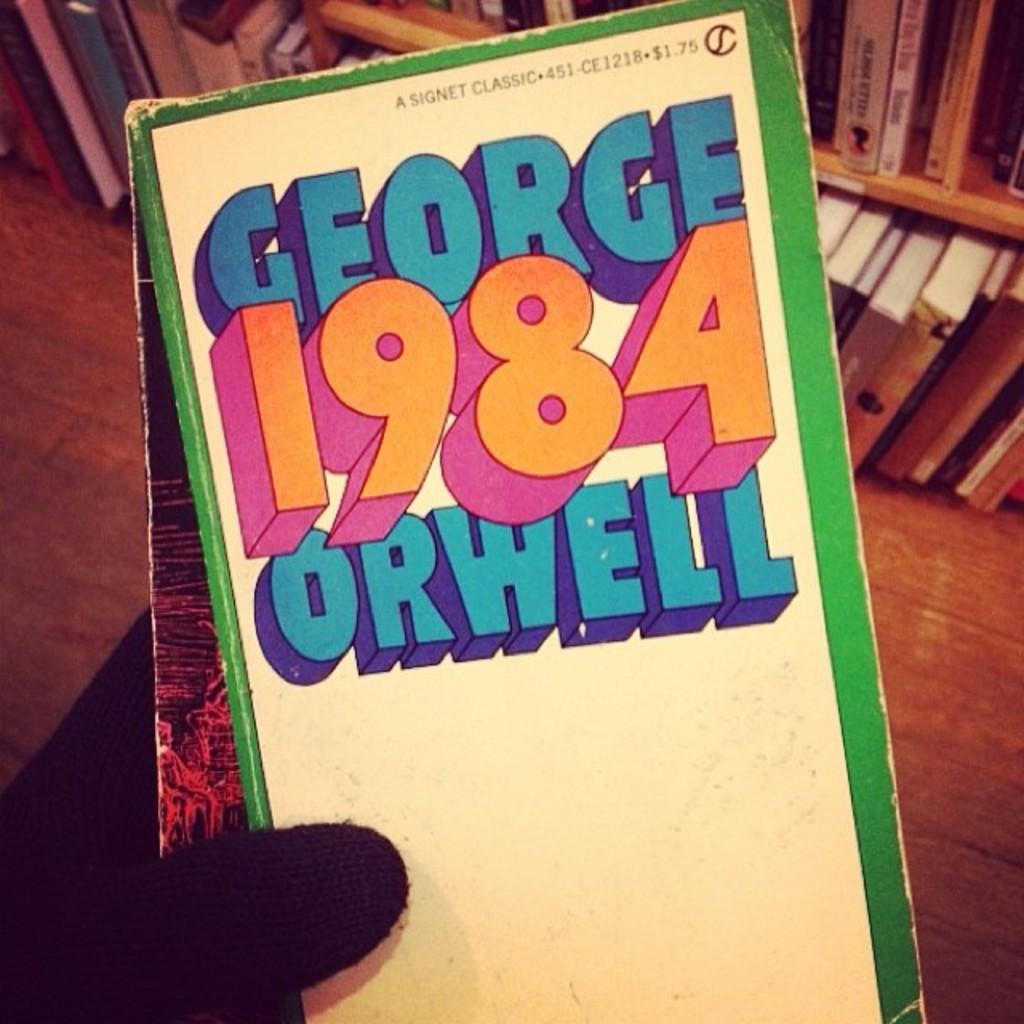What was the price?
Provide a succinct answer. 1.75. 